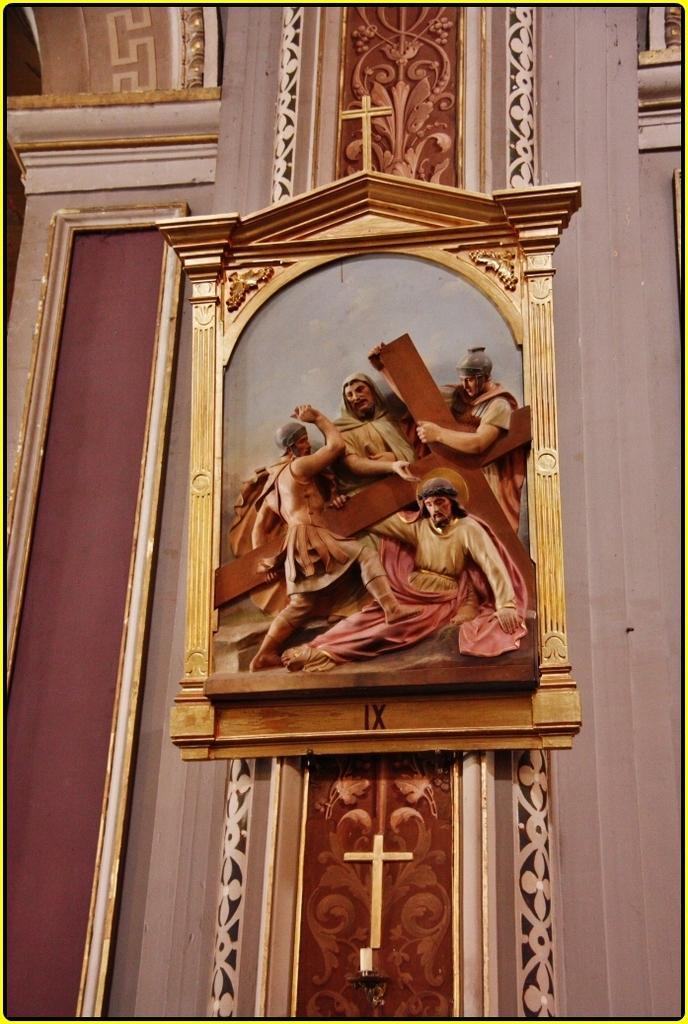Describe this image in one or two sentences. In this image there is a wall and we can see a frame placed on the wall and there are carvings on the wall. 